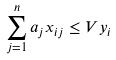<formula> <loc_0><loc_0><loc_500><loc_500>\sum _ { j = 1 } ^ { n } a _ { j } x _ { i j } \leq V y _ { i }</formula> 